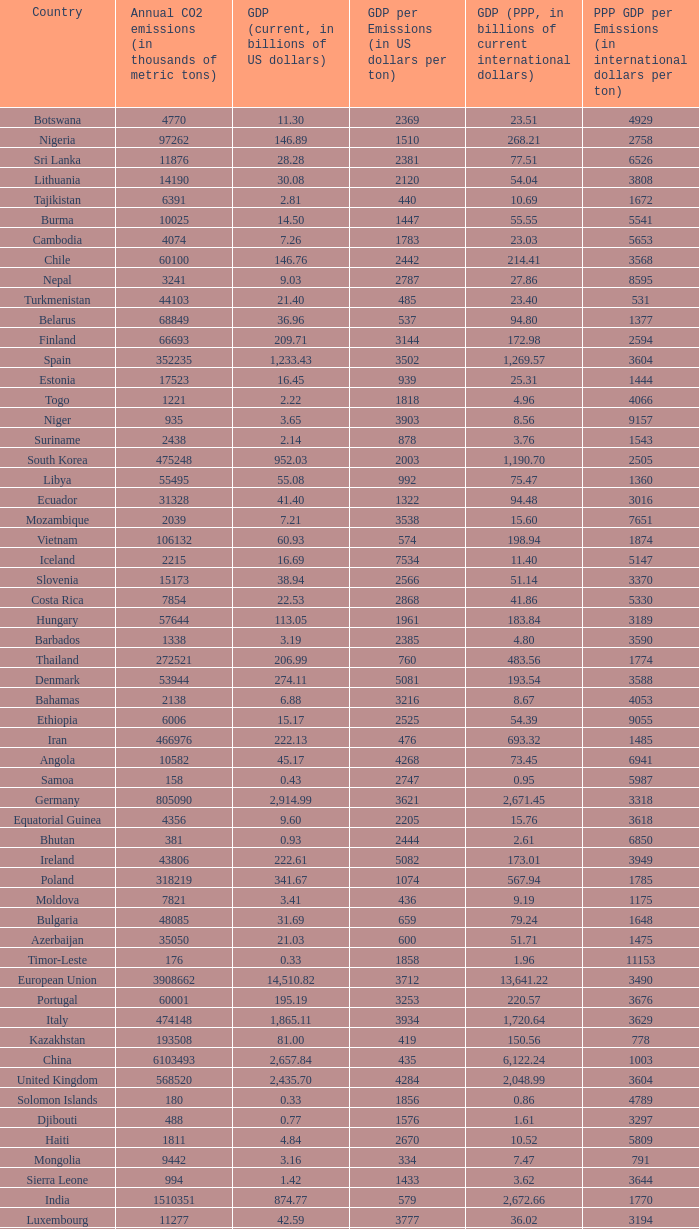When the gdp (ppp, in billions of current international dollars) is 7.93, what is the maximum ppp gdp per emissions (in international dollars per ton)? 9960.0. 